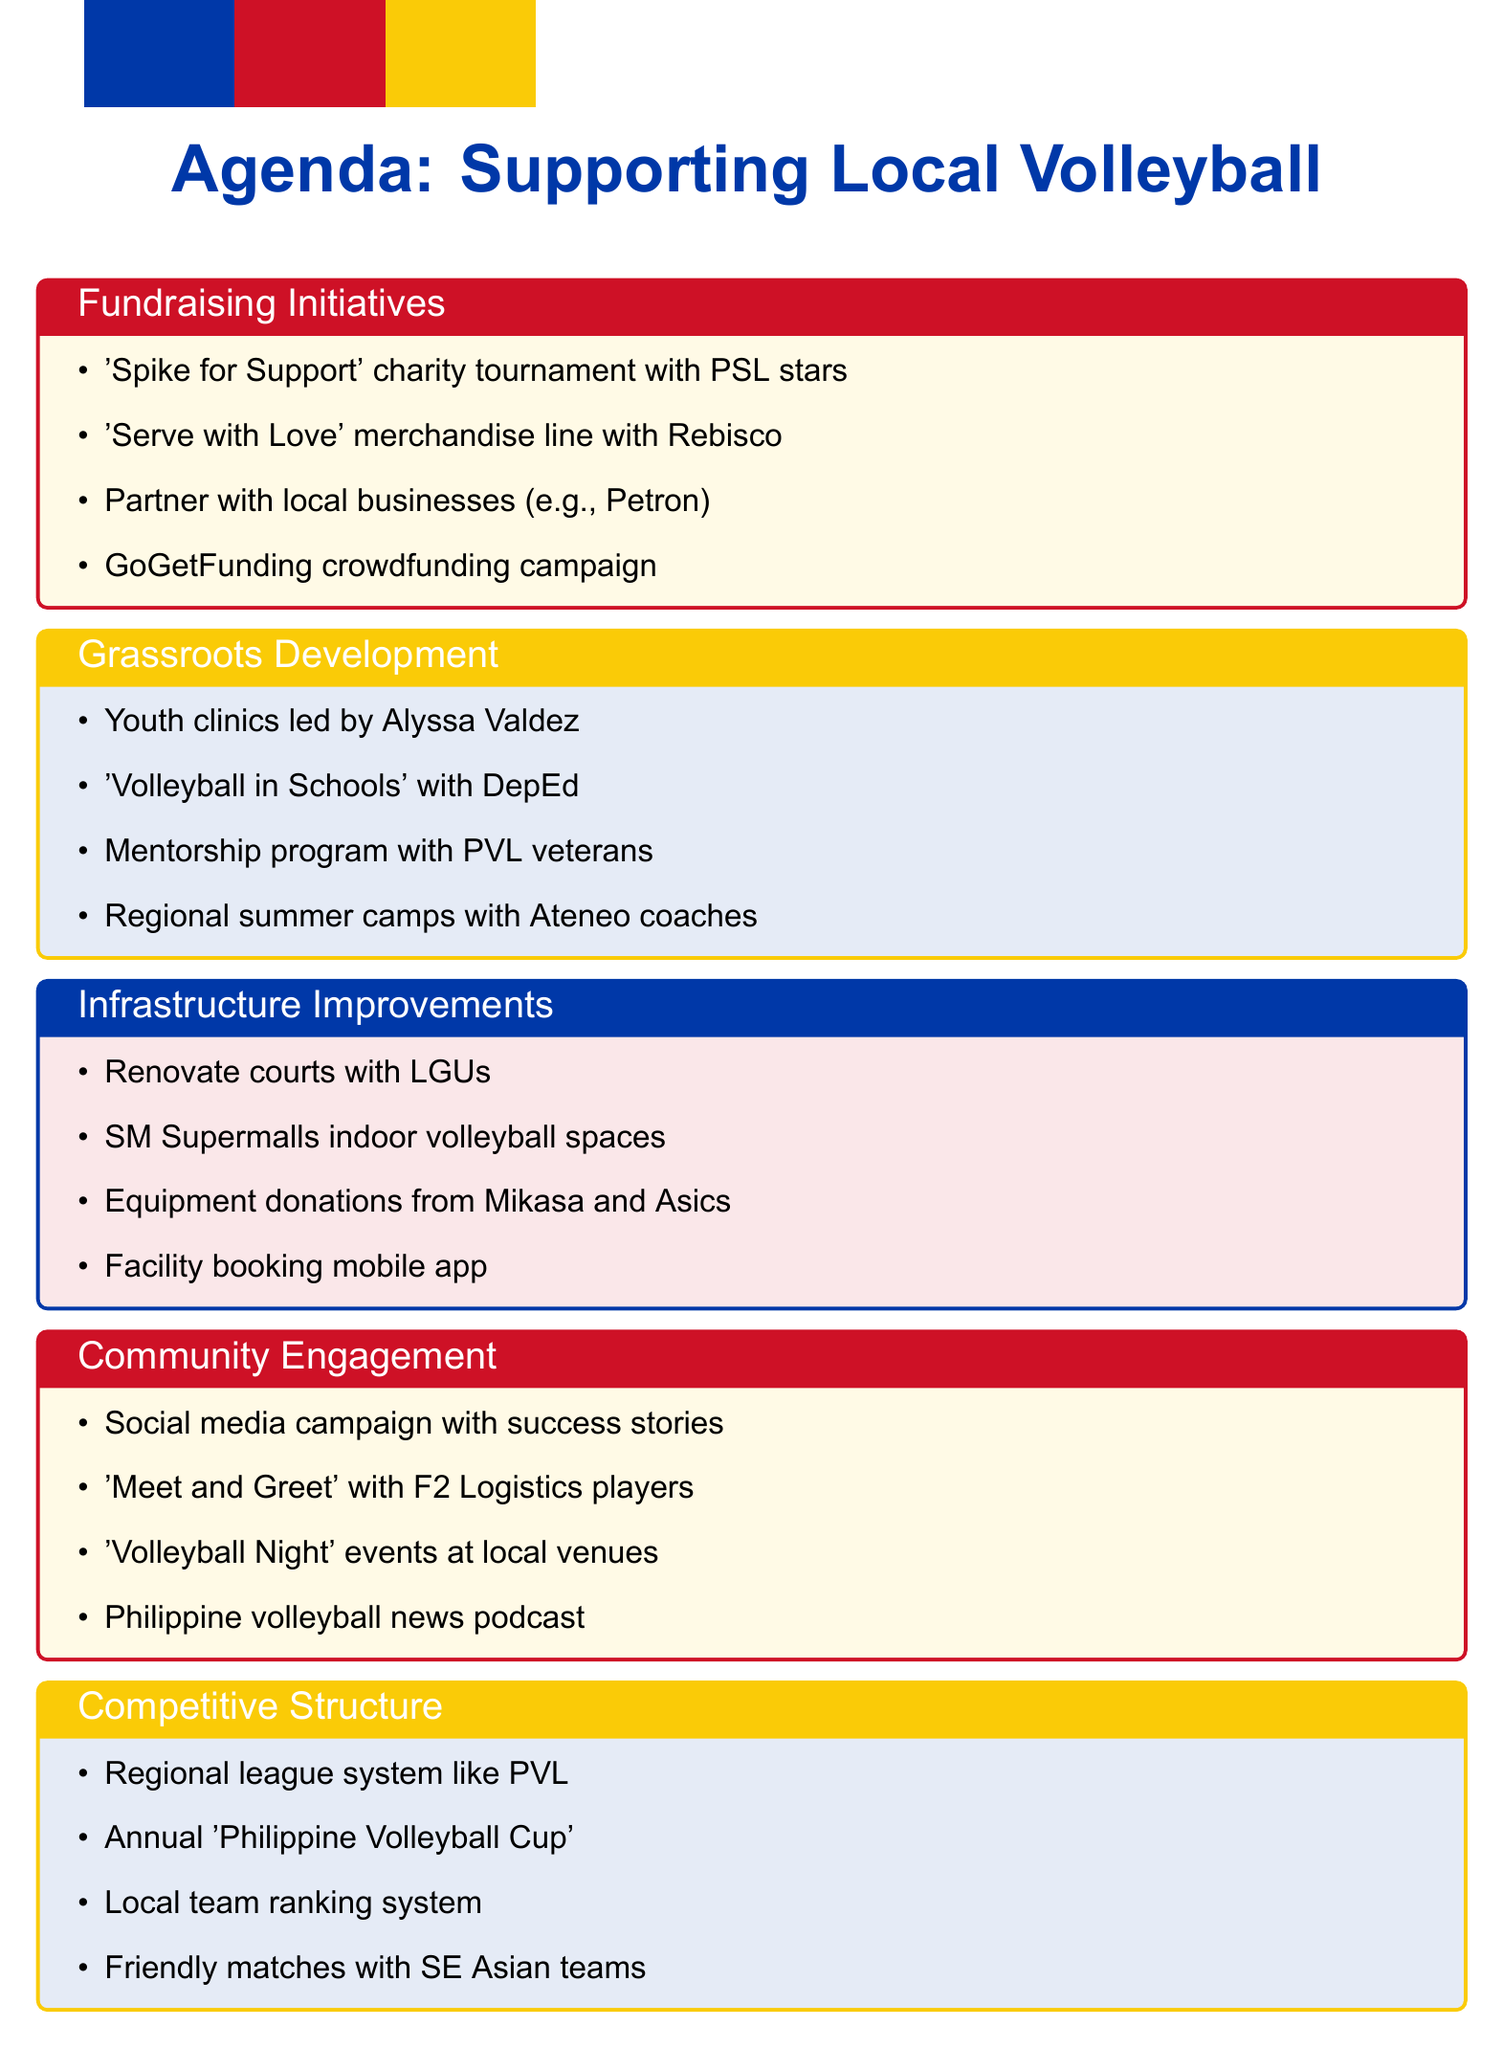What is the title of the first agenda item? The first agenda item is a specific section outlined in the document and its title is included at the beginning of that section.
Answer: Fundraising Initiatives for Local Volleyball Clubs Who is suggested to lead the youth clinics? The document specifies a prominent player who will lead the youth clinics, highlighting their role in grassroots development.
Answer: Alyssa Valdez How many types of improvements are listed under Infrastructure? The document separately outlines distinct subtopics related to the main agenda item of Infrastructure and Facility Improvements, and counting these provides the answer.
Answer: Four What merchandise line is proposed for fundraising? The document mentions a specific merchandise line aimed at raising funds for local clubs, which is clearly stated in the fundraising initiatives.
Answer: Serve with Love Which company is mentioned as a potential sponsor? The agenda includes a subtopic that identifies a local business associated with potential sponsorship opportunities, which is explicitly stated.
Answer: Petron Corporation How many community engagement activities are outlined in the document? By tallying the individual activities proposed under the Community Engagement and Awareness section, one can determine the total number mentioned.
Answer: Four What is the proposed annual tournament for local clubs called? The document provides the name of a specific tournament designed to encourage competition among local clubs, which is directly referenced.
Answer: Philippine Volleyball Cup Which international coach is invited for workshops? The agenda specifies a well-known coach who is suggested to lead workshops, making it straightforward to identify them from the document.
Answer: Tai Bundit What is the initiative to create indoor volleyball spaces? The document references a collaboration with a specific company for developing indoor volleyball facilities, which is clearly described under Infrastructure.
Answer: SM Supermalls 